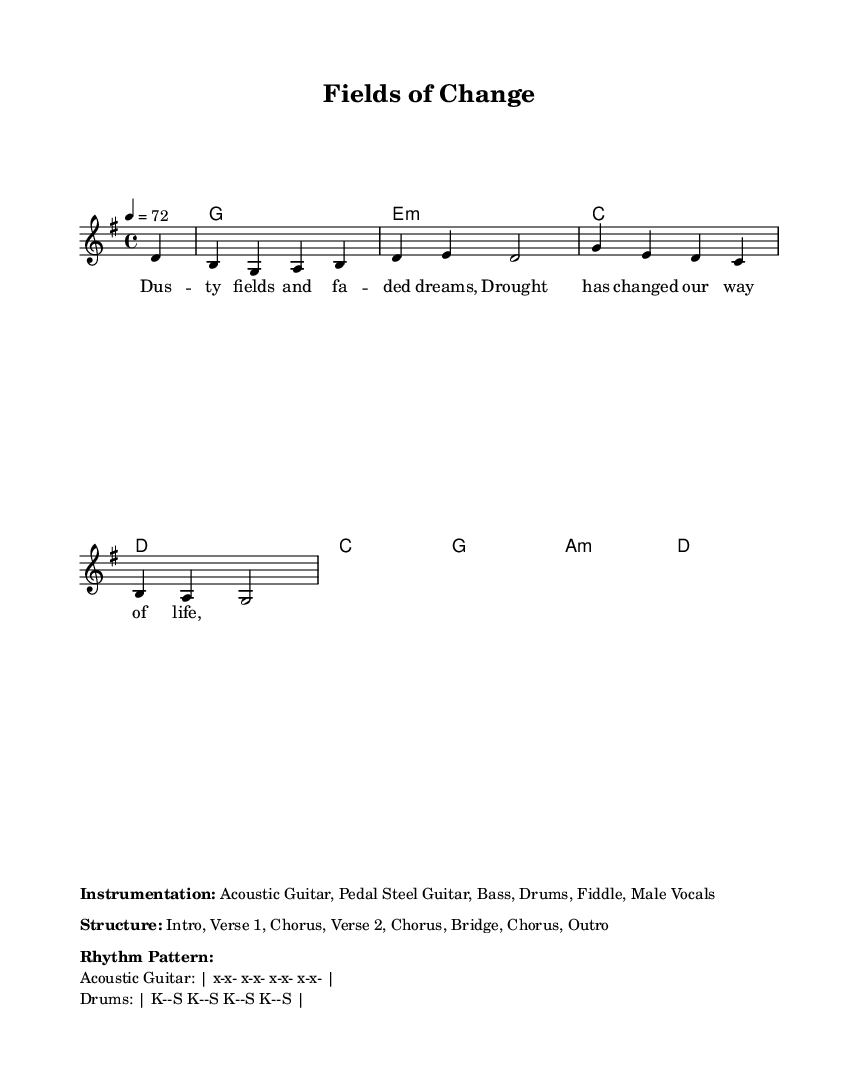What is the key signature of this music? The key signature is G major, which has one sharp (F#). This can be determined by examining the global settings in the sheet music provided.
Answer: G major What is the time signature of this music? The time signature is 4/4, indicated in the global section of the sheet music. This means there are four beats per measure, and the quarter note gets one beat.
Answer: 4/4 What is the tempo marking of this music? The tempo marking is 72 beats per minute. This is specified in the global settings, indicating how fast the piece should be played.
Answer: 72 What instruments are featured in this piece? The instrumentation listed includes Acoustic Guitar, Pedal Steel Guitar, Bass, Drums, Fiddle, and Male Vocals. This is part of the markup section that provides additional information about the performance.
Answer: Acoustic Guitar, Pedal Steel Guitar, Bass, Drums, Fiddle, Male Vocals How many verses are in the song structure? The structure includes two verses: Verse 1 and Verse 2, as detailed in the markup section describing the organization of the piece.
Answer: 2 What is the main theme addressed in the lyrics? The main theme of the lyrics speaks about drought affecting rural life, highlighted by phrases like "Dusty fields and faded dreams." These words reflect the impact of climate change on rural communities, which is the central message of the ballad.
Answer: Drought 